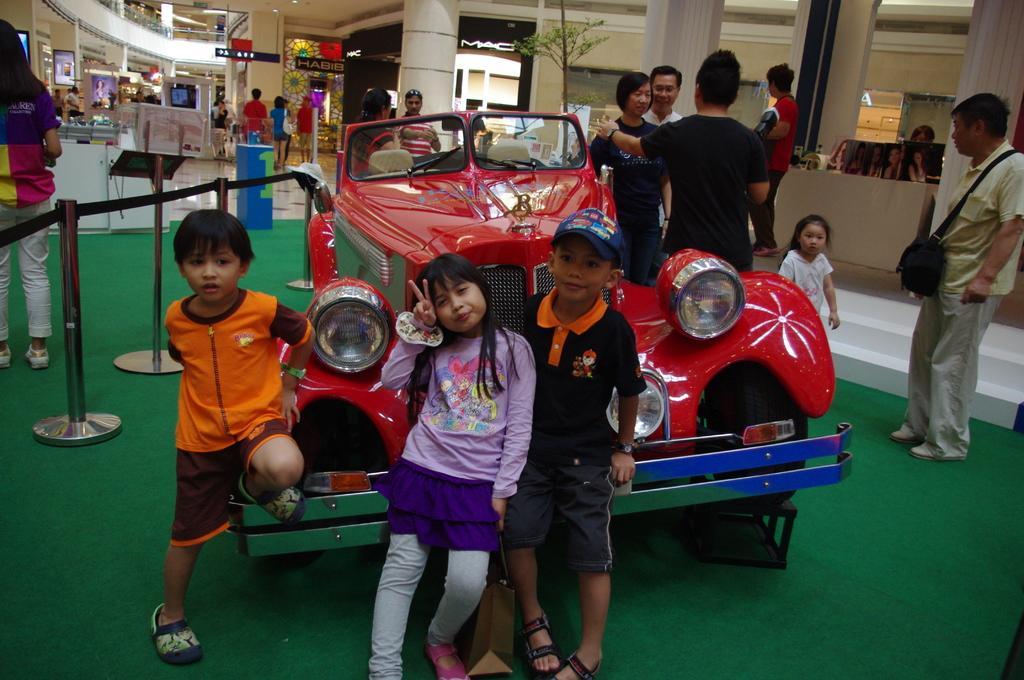Describe this image in one or two sentences. In this picture I can see group of people standing, there is a vehicle, there are stanchion barriers, there are boards, shops, pillars and there are some objects. 